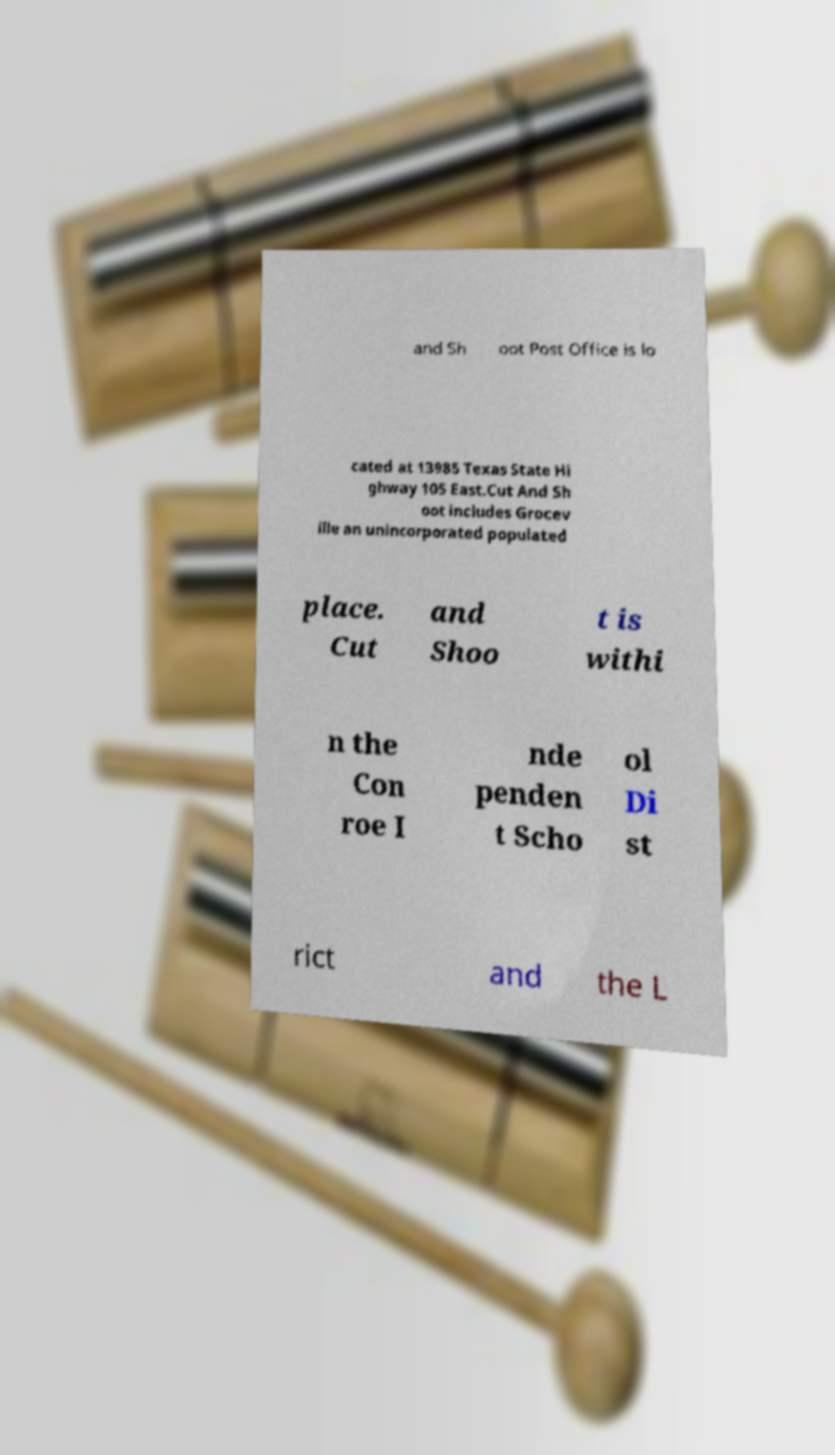There's text embedded in this image that I need extracted. Can you transcribe it verbatim? and Sh oot Post Office is lo cated at 13985 Texas State Hi ghway 105 East.Cut And Sh oot includes Grocev ille an unincorporated populated place. Cut and Shoo t is withi n the Con roe I nde penden t Scho ol Di st rict and the L 